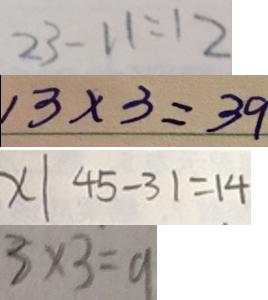Convert formula to latex. <formula><loc_0><loc_0><loc_500><loc_500>2 3 - 1 1 = 1 2 
 1 3 \times 3 = 3 9 
 x \vert 4 5 - 3 1 = 1 4 
 3 \times 3 = 9</formula> 